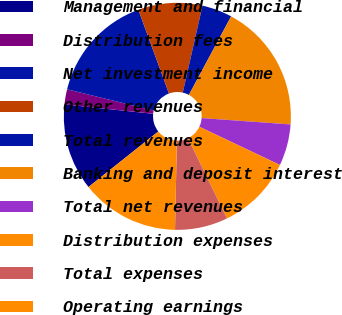Convert chart. <chart><loc_0><loc_0><loc_500><loc_500><pie_chart><fcel>Management and financial<fcel>Distribution fees<fcel>Net investment income<fcel>Other revenues<fcel>Total revenues<fcel>Banking and deposit interest<fcel>Total net revenues<fcel>Distribution expenses<fcel>Total expenses<fcel>Operating earnings<nl><fcel>12.37%<fcel>2.15%<fcel>15.59%<fcel>9.14%<fcel>4.3%<fcel>18.28%<fcel>5.91%<fcel>10.75%<fcel>7.53%<fcel>13.98%<nl></chart> 